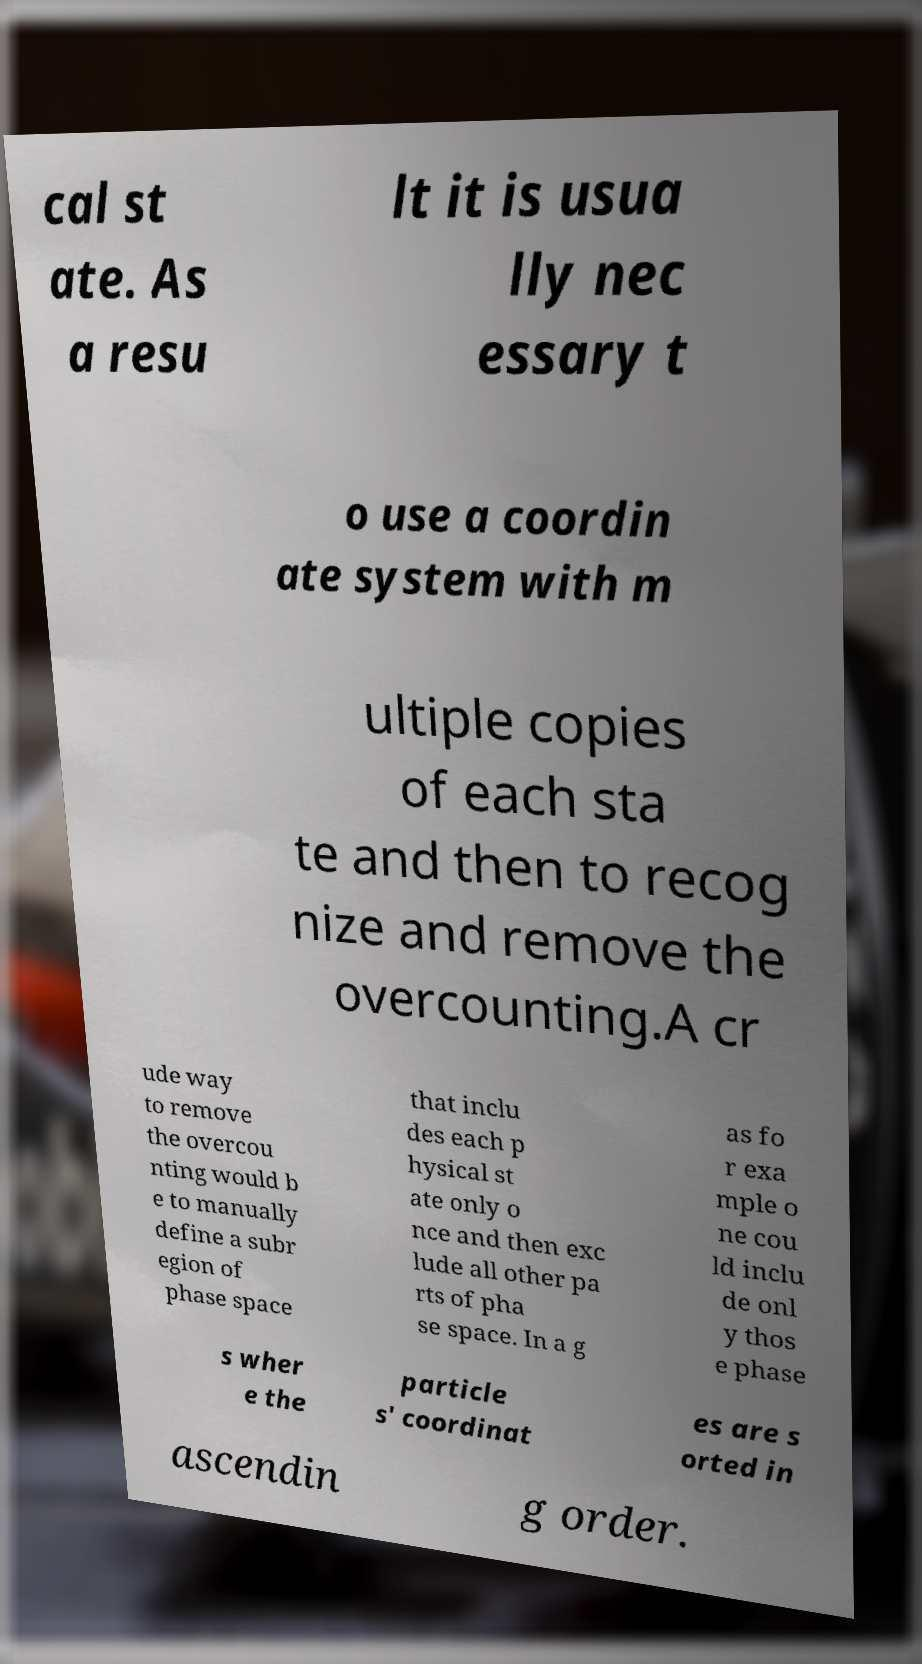Please read and relay the text visible in this image. What does it say? cal st ate. As a resu lt it is usua lly nec essary t o use a coordin ate system with m ultiple copies of each sta te and then to recog nize and remove the overcounting.A cr ude way to remove the overcou nting would b e to manually define a subr egion of phase space that inclu des each p hysical st ate only o nce and then exc lude all other pa rts of pha se space. In a g as fo r exa mple o ne cou ld inclu de onl y thos e phase s wher e the particle s' coordinat es are s orted in ascendin g order. 